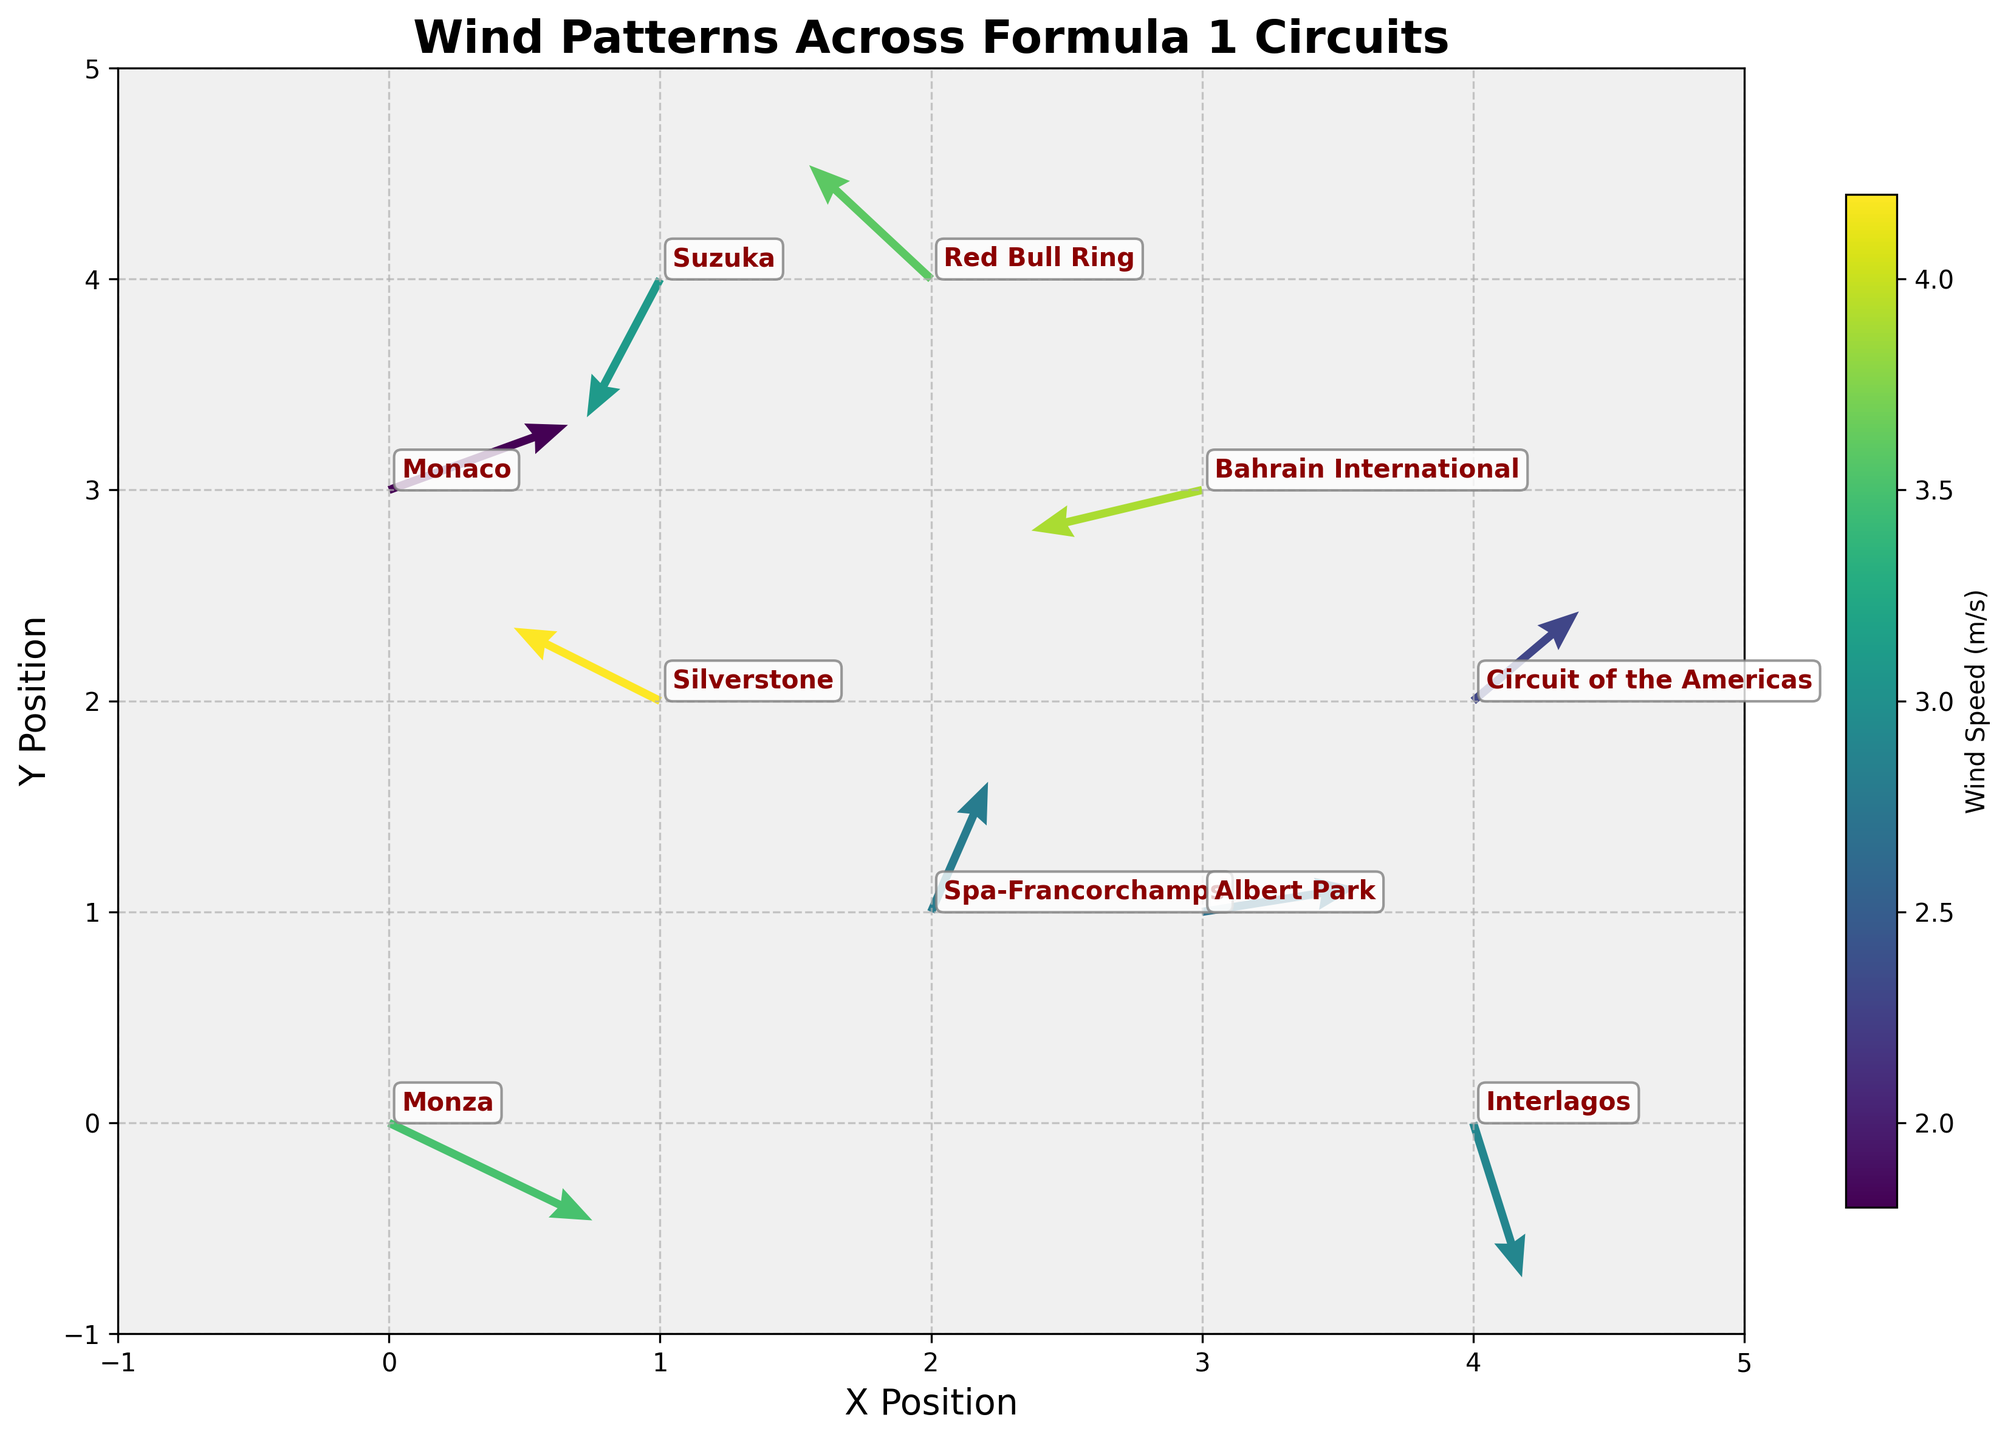What is the title of the plot? The title usually appears at the top center of the plot, summarizing its content. In this case, it is clearly "Wind Patterns Across Formula 1 Circuits."
Answer: Wind Patterns Across Formula 1 Circuits What are the labels of the x-axis and y-axis? Labels for the axes are typically displayed along the respective axes. Here, the x-axis is labeled as "X Position" and the y-axis as "Y Position."
Answer: X Position and Y Position How is the wind speed represented in the quiver plot? Wind speed is encoded in the plot's color, indicated by the color bar labeled "Wind Speed (m/s)." The color varies according to the wind speed value.
Answer: By color gradient Which circuit has the highest wind speed? To find this, look at the color bar and identify the darkest color associated with the highest wind speed. Silverstone, marked by the color corresponding to 4.2 m/s, has the highest wind speed.
Answer: Silverstone How is the direction of the wind depicted for each circuit? The direction is indicated by the orientation of the arrows. Each arrow's direction shows the wind's velocity vector across different circuits.
Answer: By the orientation of arrows Which circuits have a wind component with a positive x-direction? A positive x-direction means the u-component of the wind vector is positive. The circuits with positive u-values are Monza, Spa-Francorchamps, Circuit of the Americas, Albert Park, and Monaco.
Answer: Monza, Spa-Francorchamps, Circuit of the Americas, Albert Park, and Monaco In which circuits is the wind blowing predominantly downward? Predominantly downward wind corresponds to a significantly negative v-component. This occurs in Monza, Suzuka, and Interlagos where the v-values are highly negative.
Answer: Monza, Suzuka, and Interlagos What is the average wind speed across all circuits? Sum all wind speed values and divide by the number of circuits: (3.5 + 4.2 + 2.8 + 3.9 + 2.3 + 3.1 + 2.7 + 3.6 + 2.9 + 1.8) / 10. The calculation results in 3.08.
Answer: 3.08 m/s Which circuits have a wind component with a negative y-direction? A negative y-direction means the v-component of the wind vector is negative. Circuits with such a wind component are Monza, Bahrain International, Albert Park, Suzuka, and Interlagos.
Answer: Monza, Bahrain International, Albert Park, Suzuka, and Interlagos Do any circuits have purely horizontal or vertical winds? Purely horizontal winds have a v-component of 0 and purely vertical winds have a u-component of 0. No circuit has either zero v or u values in this dataset.
Answer: No 